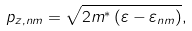<formula> <loc_0><loc_0><loc_500><loc_500>p _ { z , n m } = \sqrt { 2 m ^ { \ast } \left ( \varepsilon - \varepsilon _ { n m } \right ) } ,</formula> 